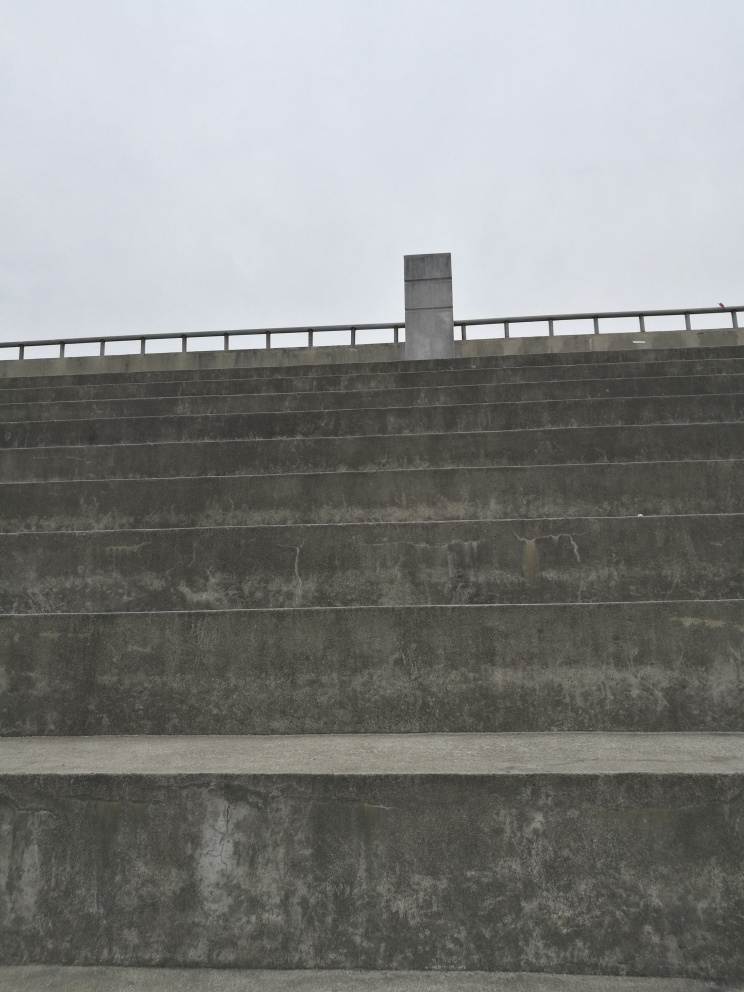What time of day does this image appear to have been taken? The overcast sky and the absence of shadows suggest that the image was likely taken on a cloudy day, which makes it challenging to determine the exact time. However, the diffused lighting implies that it could be midday when the light is usually soft and even. 